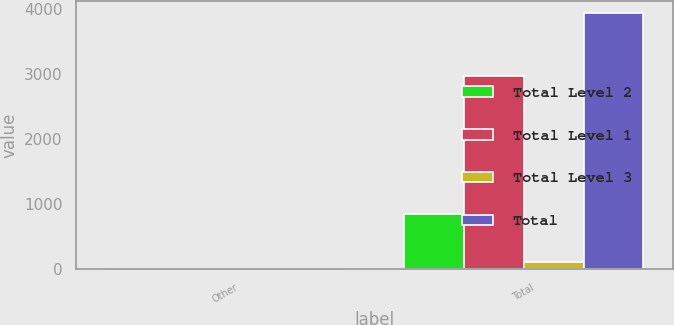<chart> <loc_0><loc_0><loc_500><loc_500><stacked_bar_chart><ecel><fcel>Other<fcel>Total<nl><fcel>Total Level 2<fcel>6<fcel>850<nl><fcel>Total Level 1<fcel>5<fcel>2969<nl><fcel>Total Level 3<fcel>6<fcel>112<nl><fcel>Total<fcel>7<fcel>3931<nl></chart> 